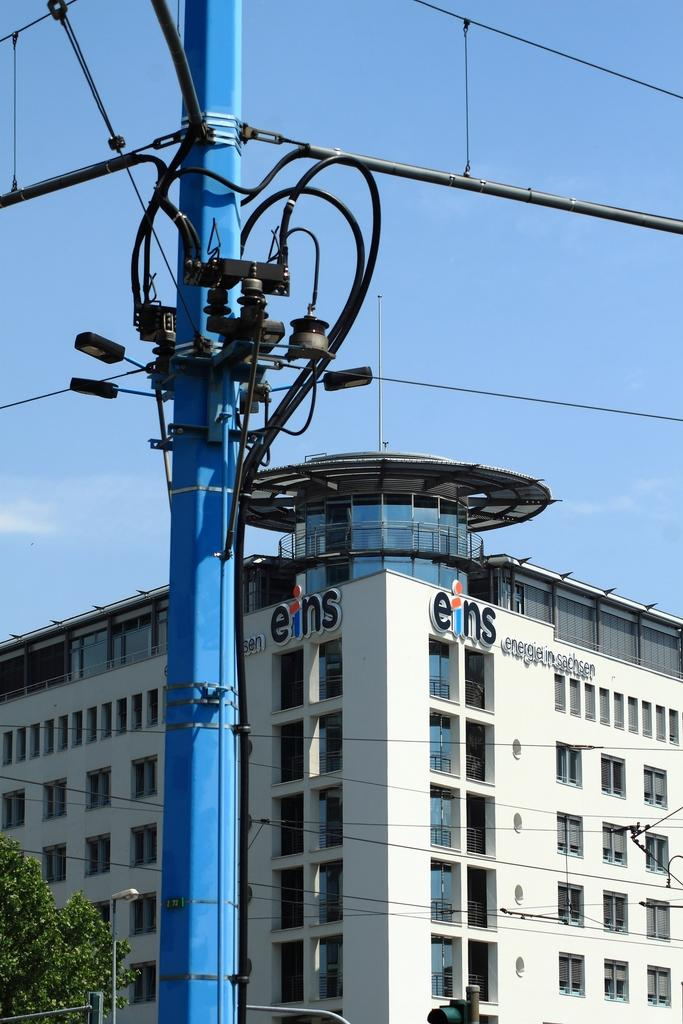What type of structure can be seen in the image? There is an electric pole in the image. What other structures can be seen in the background? There are light poles in the background of the image. What type of vegetation is present in the image? There are trees with green color in the image. What color is the building in the image? The building in the image has a white color. What color is the sky in the image? The sky is in blue color in the image. How does the field of disgust affect the image? There is no field of disgust present in the image; it is a scene with an electric pole, light poles, trees, a building, and the sky. 